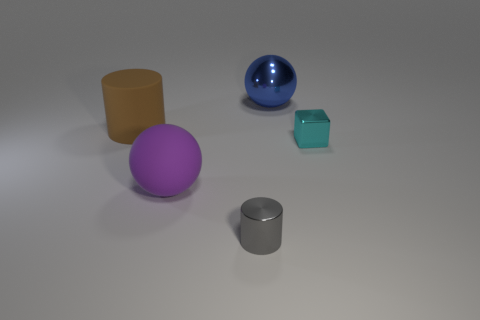Does the matte ball have the same size as the gray metallic object?
Give a very brief answer. No. What number of metal cubes have the same size as the brown object?
Make the answer very short. 0. Is the material of the ball in front of the small cyan metallic thing the same as the cylinder in front of the cyan metal block?
Provide a succinct answer. No. Is there any other thing that has the same shape as the tiny cyan thing?
Keep it short and to the point. No. The large matte ball is what color?
Your answer should be compact. Purple. How many other shiny objects are the same shape as the gray object?
Provide a succinct answer. 0. There is a rubber thing that is the same size as the purple matte ball; what color is it?
Offer a terse response. Brown. Are there any large gray rubber cylinders?
Your answer should be compact. No. What shape is the rubber object right of the big brown cylinder?
Provide a succinct answer. Sphere. How many things are both behind the tiny gray cylinder and on the right side of the purple rubber object?
Offer a terse response. 2. 